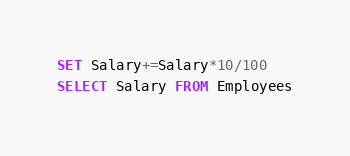<code> <loc_0><loc_0><loc_500><loc_500><_SQL_>SET Salary+=Salary*10/100
SELECT Salary FROM Employees</code> 